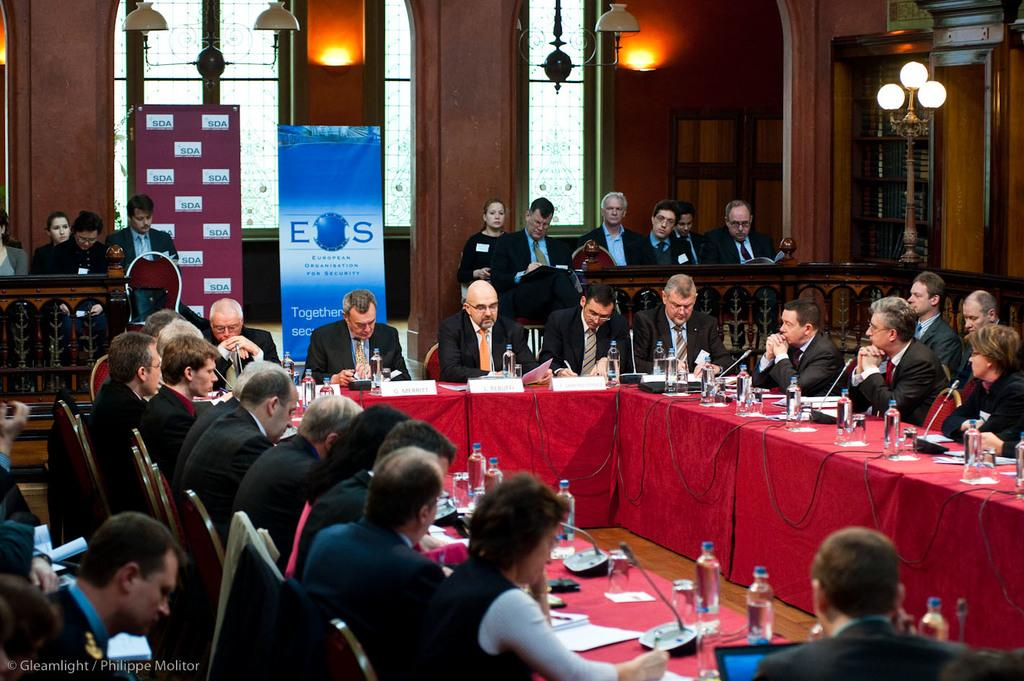What are the people in the image doing? The people in the image are sitting on chairs. Are there any other people visible in the image? Yes, there are people standing in the background of the image. What items can be seen on the table in the image? There are water bottles and paper on the table in the image. What type of jewel is being used as a paperweight on the table in the image? There is no jewel present on the table in the image; it only has paper and water bottles. 